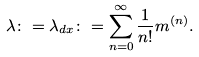<formula> <loc_0><loc_0><loc_500><loc_500>\lambda \colon = \lambda _ { d x } \colon = \sum _ { n = 0 } ^ { \infty } \frac { 1 } { n ! } m ^ { ( n ) } .</formula> 